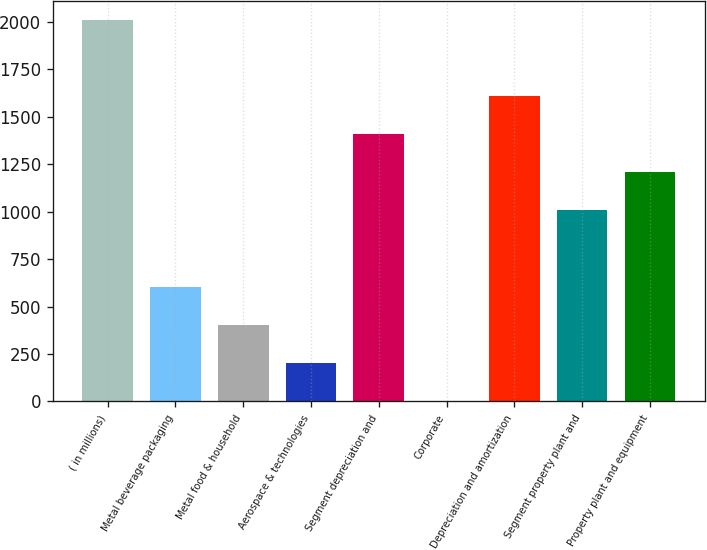Convert chart. <chart><loc_0><loc_0><loc_500><loc_500><bar_chart><fcel>( in millions)<fcel>Metal beverage packaging<fcel>Metal food & household<fcel>Aerospace & technologies<fcel>Segment depreciation and<fcel>Corporate<fcel>Depreciation and amortization<fcel>Segment property plant and<fcel>Property plant and equipment<nl><fcel>2010<fcel>605.73<fcel>405.12<fcel>204.51<fcel>1408.17<fcel>3.9<fcel>1608.78<fcel>1006.95<fcel>1207.56<nl></chart> 